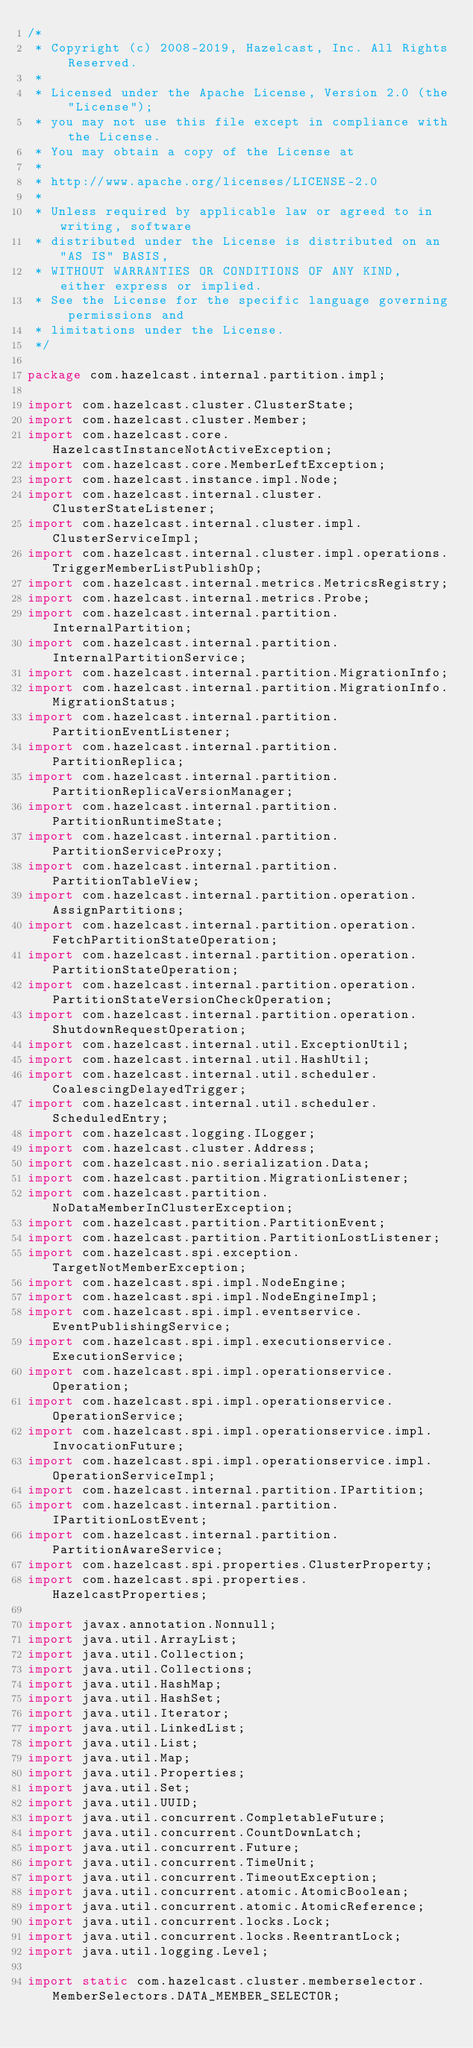Convert code to text. <code><loc_0><loc_0><loc_500><loc_500><_Java_>/*
 * Copyright (c) 2008-2019, Hazelcast, Inc. All Rights Reserved.
 *
 * Licensed under the Apache License, Version 2.0 (the "License");
 * you may not use this file except in compliance with the License.
 * You may obtain a copy of the License at
 *
 * http://www.apache.org/licenses/LICENSE-2.0
 *
 * Unless required by applicable law or agreed to in writing, software
 * distributed under the License is distributed on an "AS IS" BASIS,
 * WITHOUT WARRANTIES OR CONDITIONS OF ANY KIND, either express or implied.
 * See the License for the specific language governing permissions and
 * limitations under the License.
 */

package com.hazelcast.internal.partition.impl;

import com.hazelcast.cluster.ClusterState;
import com.hazelcast.cluster.Member;
import com.hazelcast.core.HazelcastInstanceNotActiveException;
import com.hazelcast.core.MemberLeftException;
import com.hazelcast.instance.impl.Node;
import com.hazelcast.internal.cluster.ClusterStateListener;
import com.hazelcast.internal.cluster.impl.ClusterServiceImpl;
import com.hazelcast.internal.cluster.impl.operations.TriggerMemberListPublishOp;
import com.hazelcast.internal.metrics.MetricsRegistry;
import com.hazelcast.internal.metrics.Probe;
import com.hazelcast.internal.partition.InternalPartition;
import com.hazelcast.internal.partition.InternalPartitionService;
import com.hazelcast.internal.partition.MigrationInfo;
import com.hazelcast.internal.partition.MigrationInfo.MigrationStatus;
import com.hazelcast.internal.partition.PartitionEventListener;
import com.hazelcast.internal.partition.PartitionReplica;
import com.hazelcast.internal.partition.PartitionReplicaVersionManager;
import com.hazelcast.internal.partition.PartitionRuntimeState;
import com.hazelcast.internal.partition.PartitionServiceProxy;
import com.hazelcast.internal.partition.PartitionTableView;
import com.hazelcast.internal.partition.operation.AssignPartitions;
import com.hazelcast.internal.partition.operation.FetchPartitionStateOperation;
import com.hazelcast.internal.partition.operation.PartitionStateOperation;
import com.hazelcast.internal.partition.operation.PartitionStateVersionCheckOperation;
import com.hazelcast.internal.partition.operation.ShutdownRequestOperation;
import com.hazelcast.internal.util.ExceptionUtil;
import com.hazelcast.internal.util.HashUtil;
import com.hazelcast.internal.util.scheduler.CoalescingDelayedTrigger;
import com.hazelcast.internal.util.scheduler.ScheduledEntry;
import com.hazelcast.logging.ILogger;
import com.hazelcast.cluster.Address;
import com.hazelcast.nio.serialization.Data;
import com.hazelcast.partition.MigrationListener;
import com.hazelcast.partition.NoDataMemberInClusterException;
import com.hazelcast.partition.PartitionEvent;
import com.hazelcast.partition.PartitionLostListener;
import com.hazelcast.spi.exception.TargetNotMemberException;
import com.hazelcast.spi.impl.NodeEngine;
import com.hazelcast.spi.impl.NodeEngineImpl;
import com.hazelcast.spi.impl.eventservice.EventPublishingService;
import com.hazelcast.spi.impl.executionservice.ExecutionService;
import com.hazelcast.spi.impl.operationservice.Operation;
import com.hazelcast.spi.impl.operationservice.OperationService;
import com.hazelcast.spi.impl.operationservice.impl.InvocationFuture;
import com.hazelcast.spi.impl.operationservice.impl.OperationServiceImpl;
import com.hazelcast.internal.partition.IPartition;
import com.hazelcast.internal.partition.IPartitionLostEvent;
import com.hazelcast.internal.partition.PartitionAwareService;
import com.hazelcast.spi.properties.ClusterProperty;
import com.hazelcast.spi.properties.HazelcastProperties;

import javax.annotation.Nonnull;
import java.util.ArrayList;
import java.util.Collection;
import java.util.Collections;
import java.util.HashMap;
import java.util.HashSet;
import java.util.Iterator;
import java.util.LinkedList;
import java.util.List;
import java.util.Map;
import java.util.Properties;
import java.util.Set;
import java.util.UUID;
import java.util.concurrent.CompletableFuture;
import java.util.concurrent.CountDownLatch;
import java.util.concurrent.Future;
import java.util.concurrent.TimeUnit;
import java.util.concurrent.TimeoutException;
import java.util.concurrent.atomic.AtomicBoolean;
import java.util.concurrent.atomic.AtomicReference;
import java.util.concurrent.locks.Lock;
import java.util.concurrent.locks.ReentrantLock;
import java.util.logging.Level;

import static com.hazelcast.cluster.memberselector.MemberSelectors.DATA_MEMBER_SELECTOR;</code> 